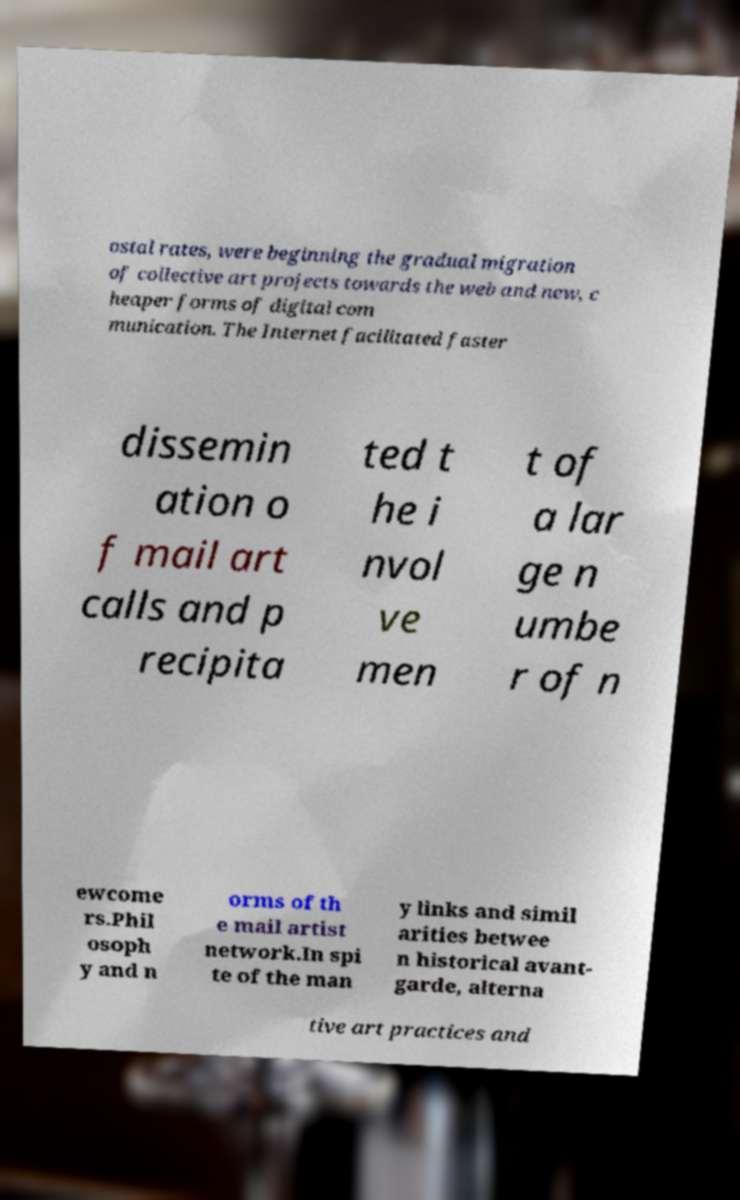What messages or text are displayed in this image? I need them in a readable, typed format. ostal rates, were beginning the gradual migration of collective art projects towards the web and new, c heaper forms of digital com munication. The Internet facilitated faster dissemin ation o f mail art calls and p recipita ted t he i nvol ve men t of a lar ge n umbe r of n ewcome rs.Phil osoph y and n orms of th e mail artist network.In spi te of the man y links and simil arities betwee n historical avant- garde, alterna tive art practices and 